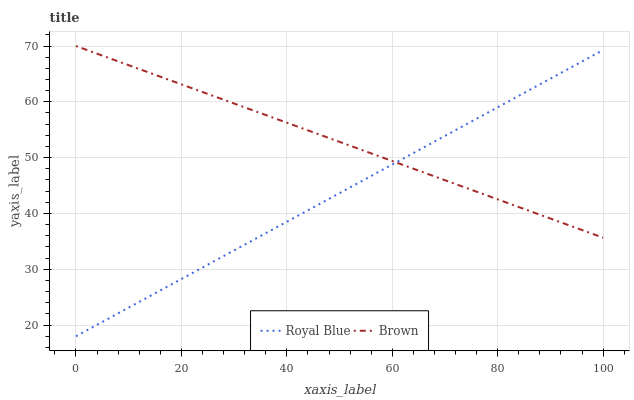Does Brown have the minimum area under the curve?
Answer yes or no. No. Is Brown the roughest?
Answer yes or no. No. Does Brown have the lowest value?
Answer yes or no. No. 